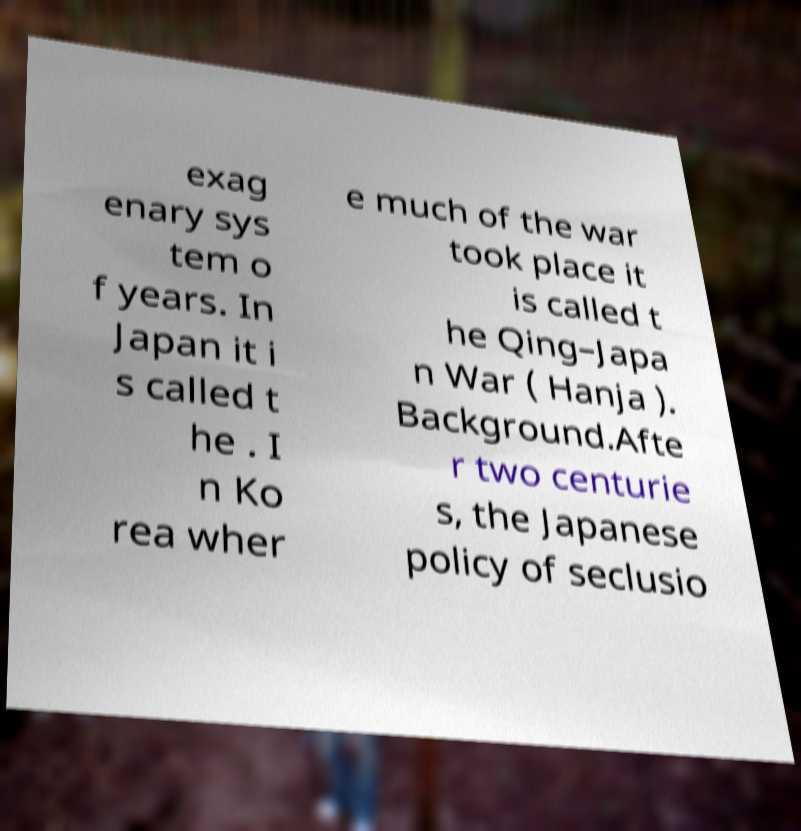Can you accurately transcribe the text from the provided image for me? exag enary sys tem o f years. In Japan it i s called t he . I n Ko rea wher e much of the war took place it is called t he Qing–Japa n War ( Hanja ). Background.Afte r two centurie s, the Japanese policy of seclusio 